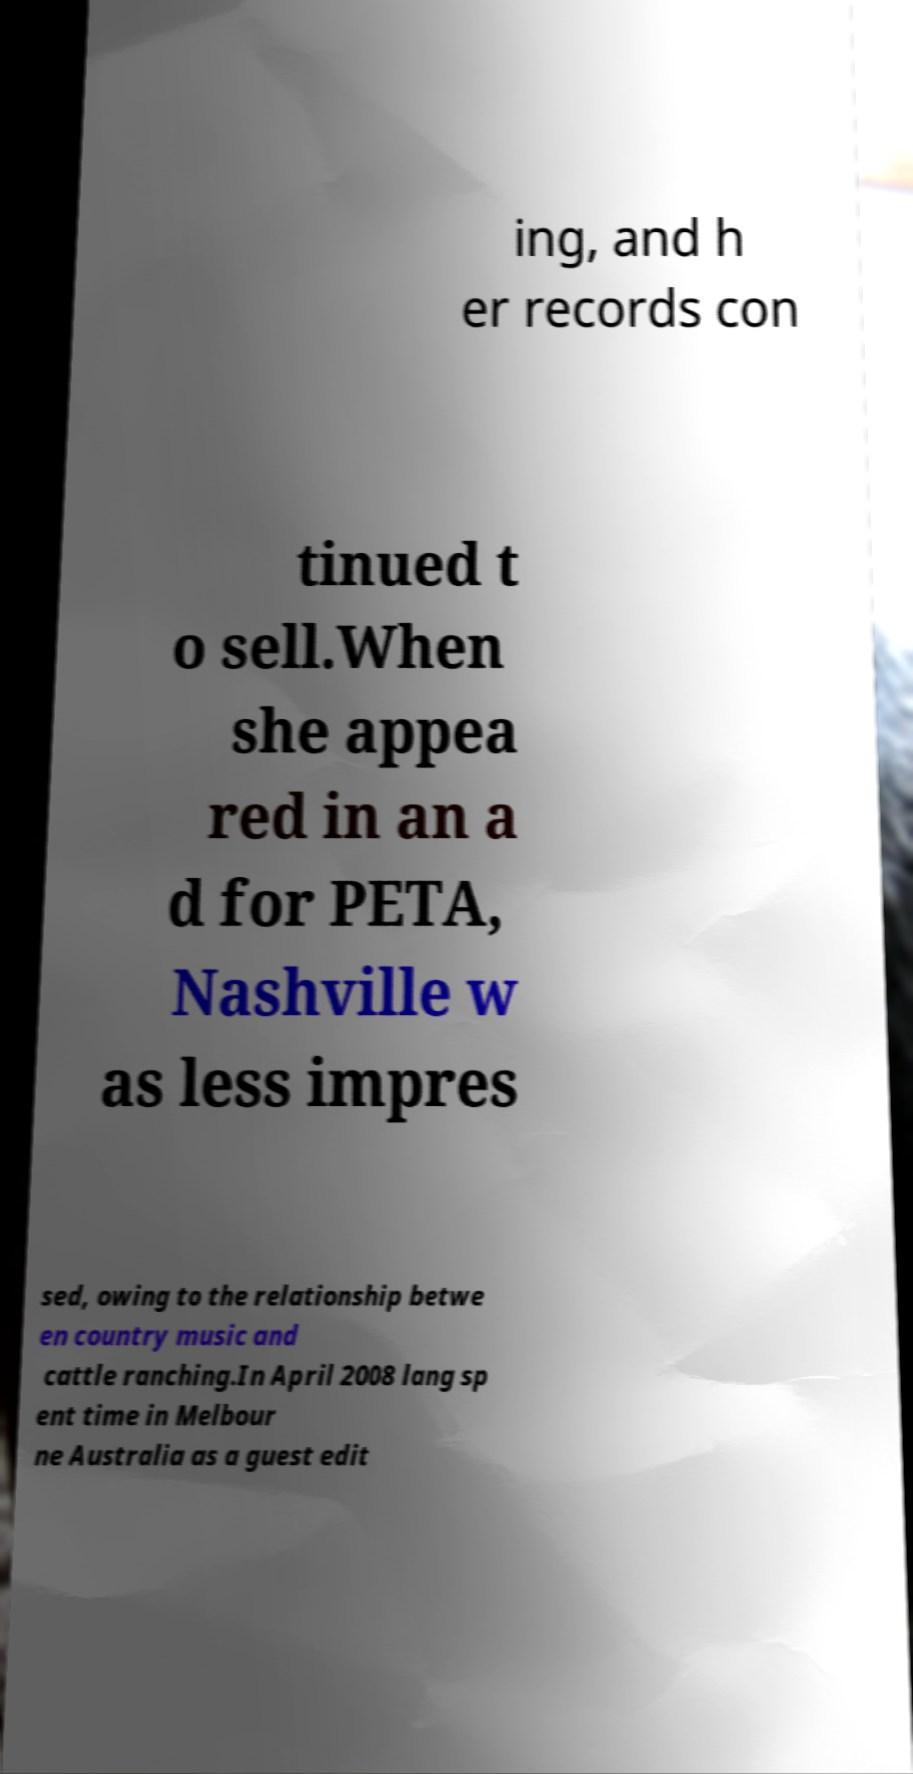I need the written content from this picture converted into text. Can you do that? ing, and h er records con tinued t o sell.When she appea red in an a d for PETA, Nashville w as less impres sed, owing to the relationship betwe en country music and cattle ranching.In April 2008 lang sp ent time in Melbour ne Australia as a guest edit 